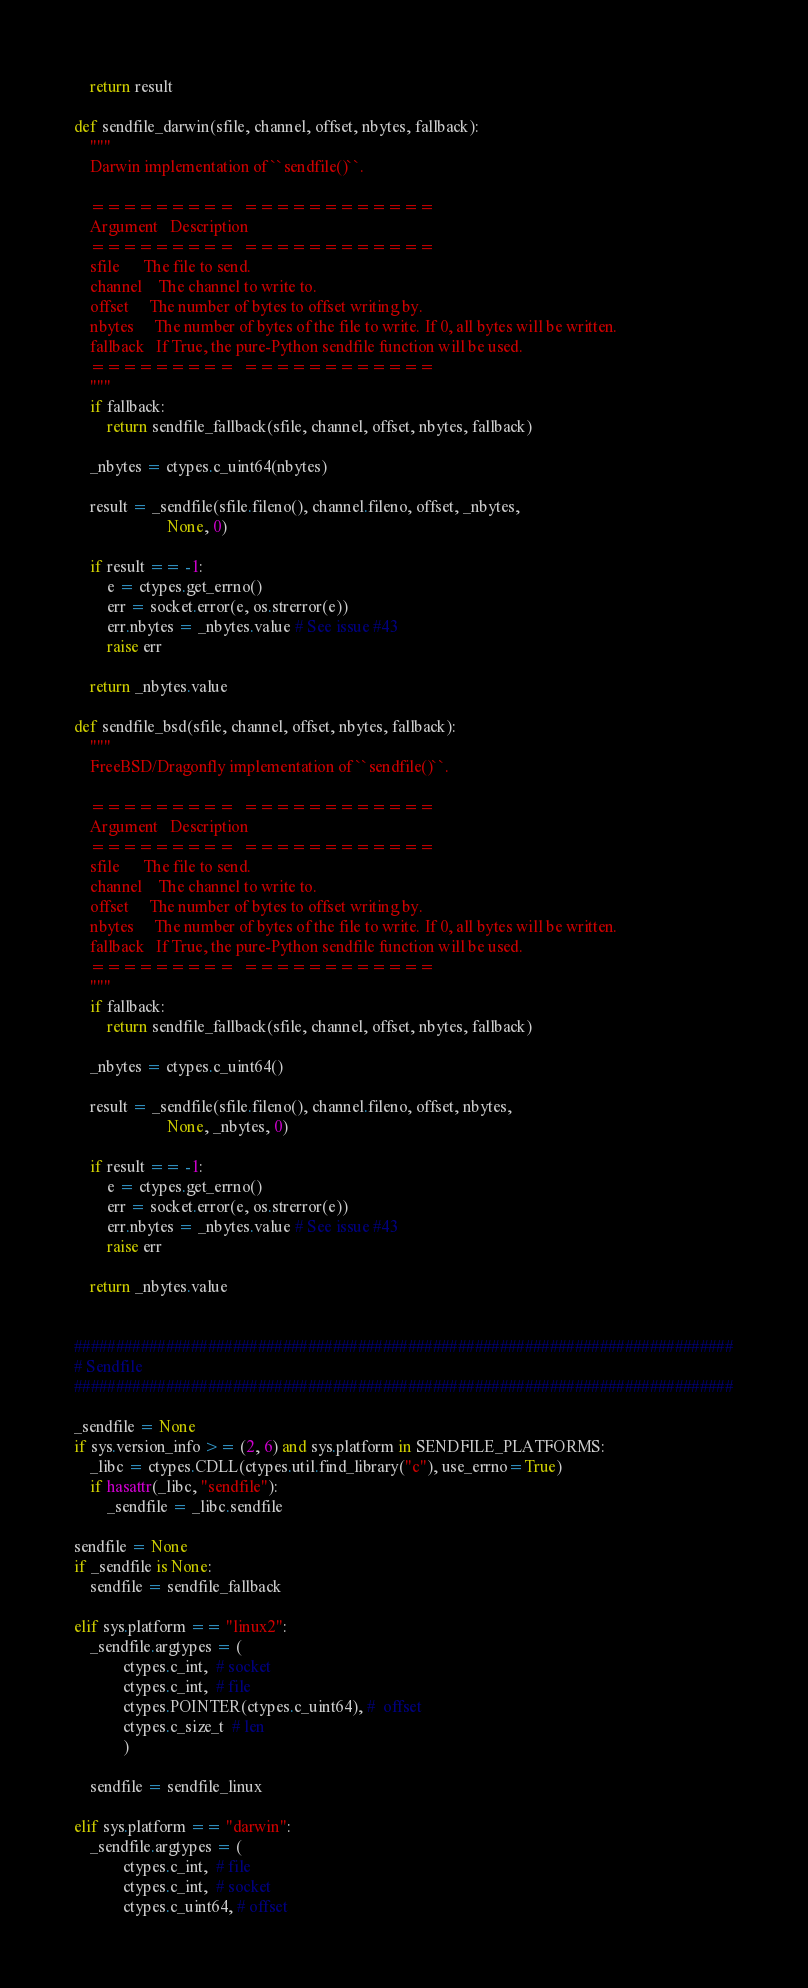Convert code to text. <code><loc_0><loc_0><loc_500><loc_500><_Python_>
    return result

def sendfile_darwin(sfile, channel, offset, nbytes, fallback):
    """
    Darwin implementation of ``sendfile()``.

    =========  ============
    Argument   Description
    =========  ============
    sfile      The file to send.
    channel    The channel to write to.
    offset     The number of bytes to offset writing by.
    nbytes     The number of bytes of the file to write. If 0, all bytes will be written.
    fallback   If True, the pure-Python sendfile function will be used.
    =========  ============
    """
    if fallback:
        return sendfile_fallback(sfile, channel, offset, nbytes, fallback)

    _nbytes = ctypes.c_uint64(nbytes)

    result = _sendfile(sfile.fileno(), channel.fileno, offset, _nbytes,
                       None, 0)

    if result == -1:
        e = ctypes.get_errno()
        err = socket.error(e, os.strerror(e))
        err.nbytes = _nbytes.value # See issue #43
        raise err

    return _nbytes.value

def sendfile_bsd(sfile, channel, offset, nbytes, fallback):
    """
    FreeBSD/Dragonfly implementation of ``sendfile()``.

    =========  ============
    Argument   Description
    =========  ============
    sfile      The file to send.
    channel    The channel to write to.
    offset     The number of bytes to offset writing by.
    nbytes     The number of bytes of the file to write. If 0, all bytes will be written.
    fallback   If True, the pure-Python sendfile function will be used.
    =========  ============
    """
    if fallback:
        return sendfile_fallback(sfile, channel, offset, nbytes, fallback)

    _nbytes = ctypes.c_uint64()

    result = _sendfile(sfile.fileno(), channel.fileno, offset, nbytes,
                       None, _nbytes, 0)

    if result == -1:
        e = ctypes.get_errno()
        err = socket.error(e, os.strerror(e))
        err.nbytes = _nbytes.value # See issue #43
        raise err

    return _nbytes.value


###############################################################################
# Sendfile
###############################################################################

_sendfile = None
if sys.version_info >= (2, 6) and sys.platform in SENDFILE_PLATFORMS:
    _libc = ctypes.CDLL(ctypes.util.find_library("c"), use_errno=True)
    if hasattr(_libc, "sendfile"):
        _sendfile = _libc.sendfile

sendfile = None
if _sendfile is None:
    sendfile = sendfile_fallback

elif sys.platform == "linux2":
    _sendfile.argtypes = (
            ctypes.c_int,  # socket
            ctypes.c_int,  # file
            ctypes.POINTER(ctypes.c_uint64), #  offset
            ctypes.c_size_t  # len
            )

    sendfile = sendfile_linux

elif sys.platform == "darwin":
    _sendfile.argtypes = (
            ctypes.c_int,  # file
            ctypes.c_int,  # socket
            ctypes.c_uint64, # offset</code> 